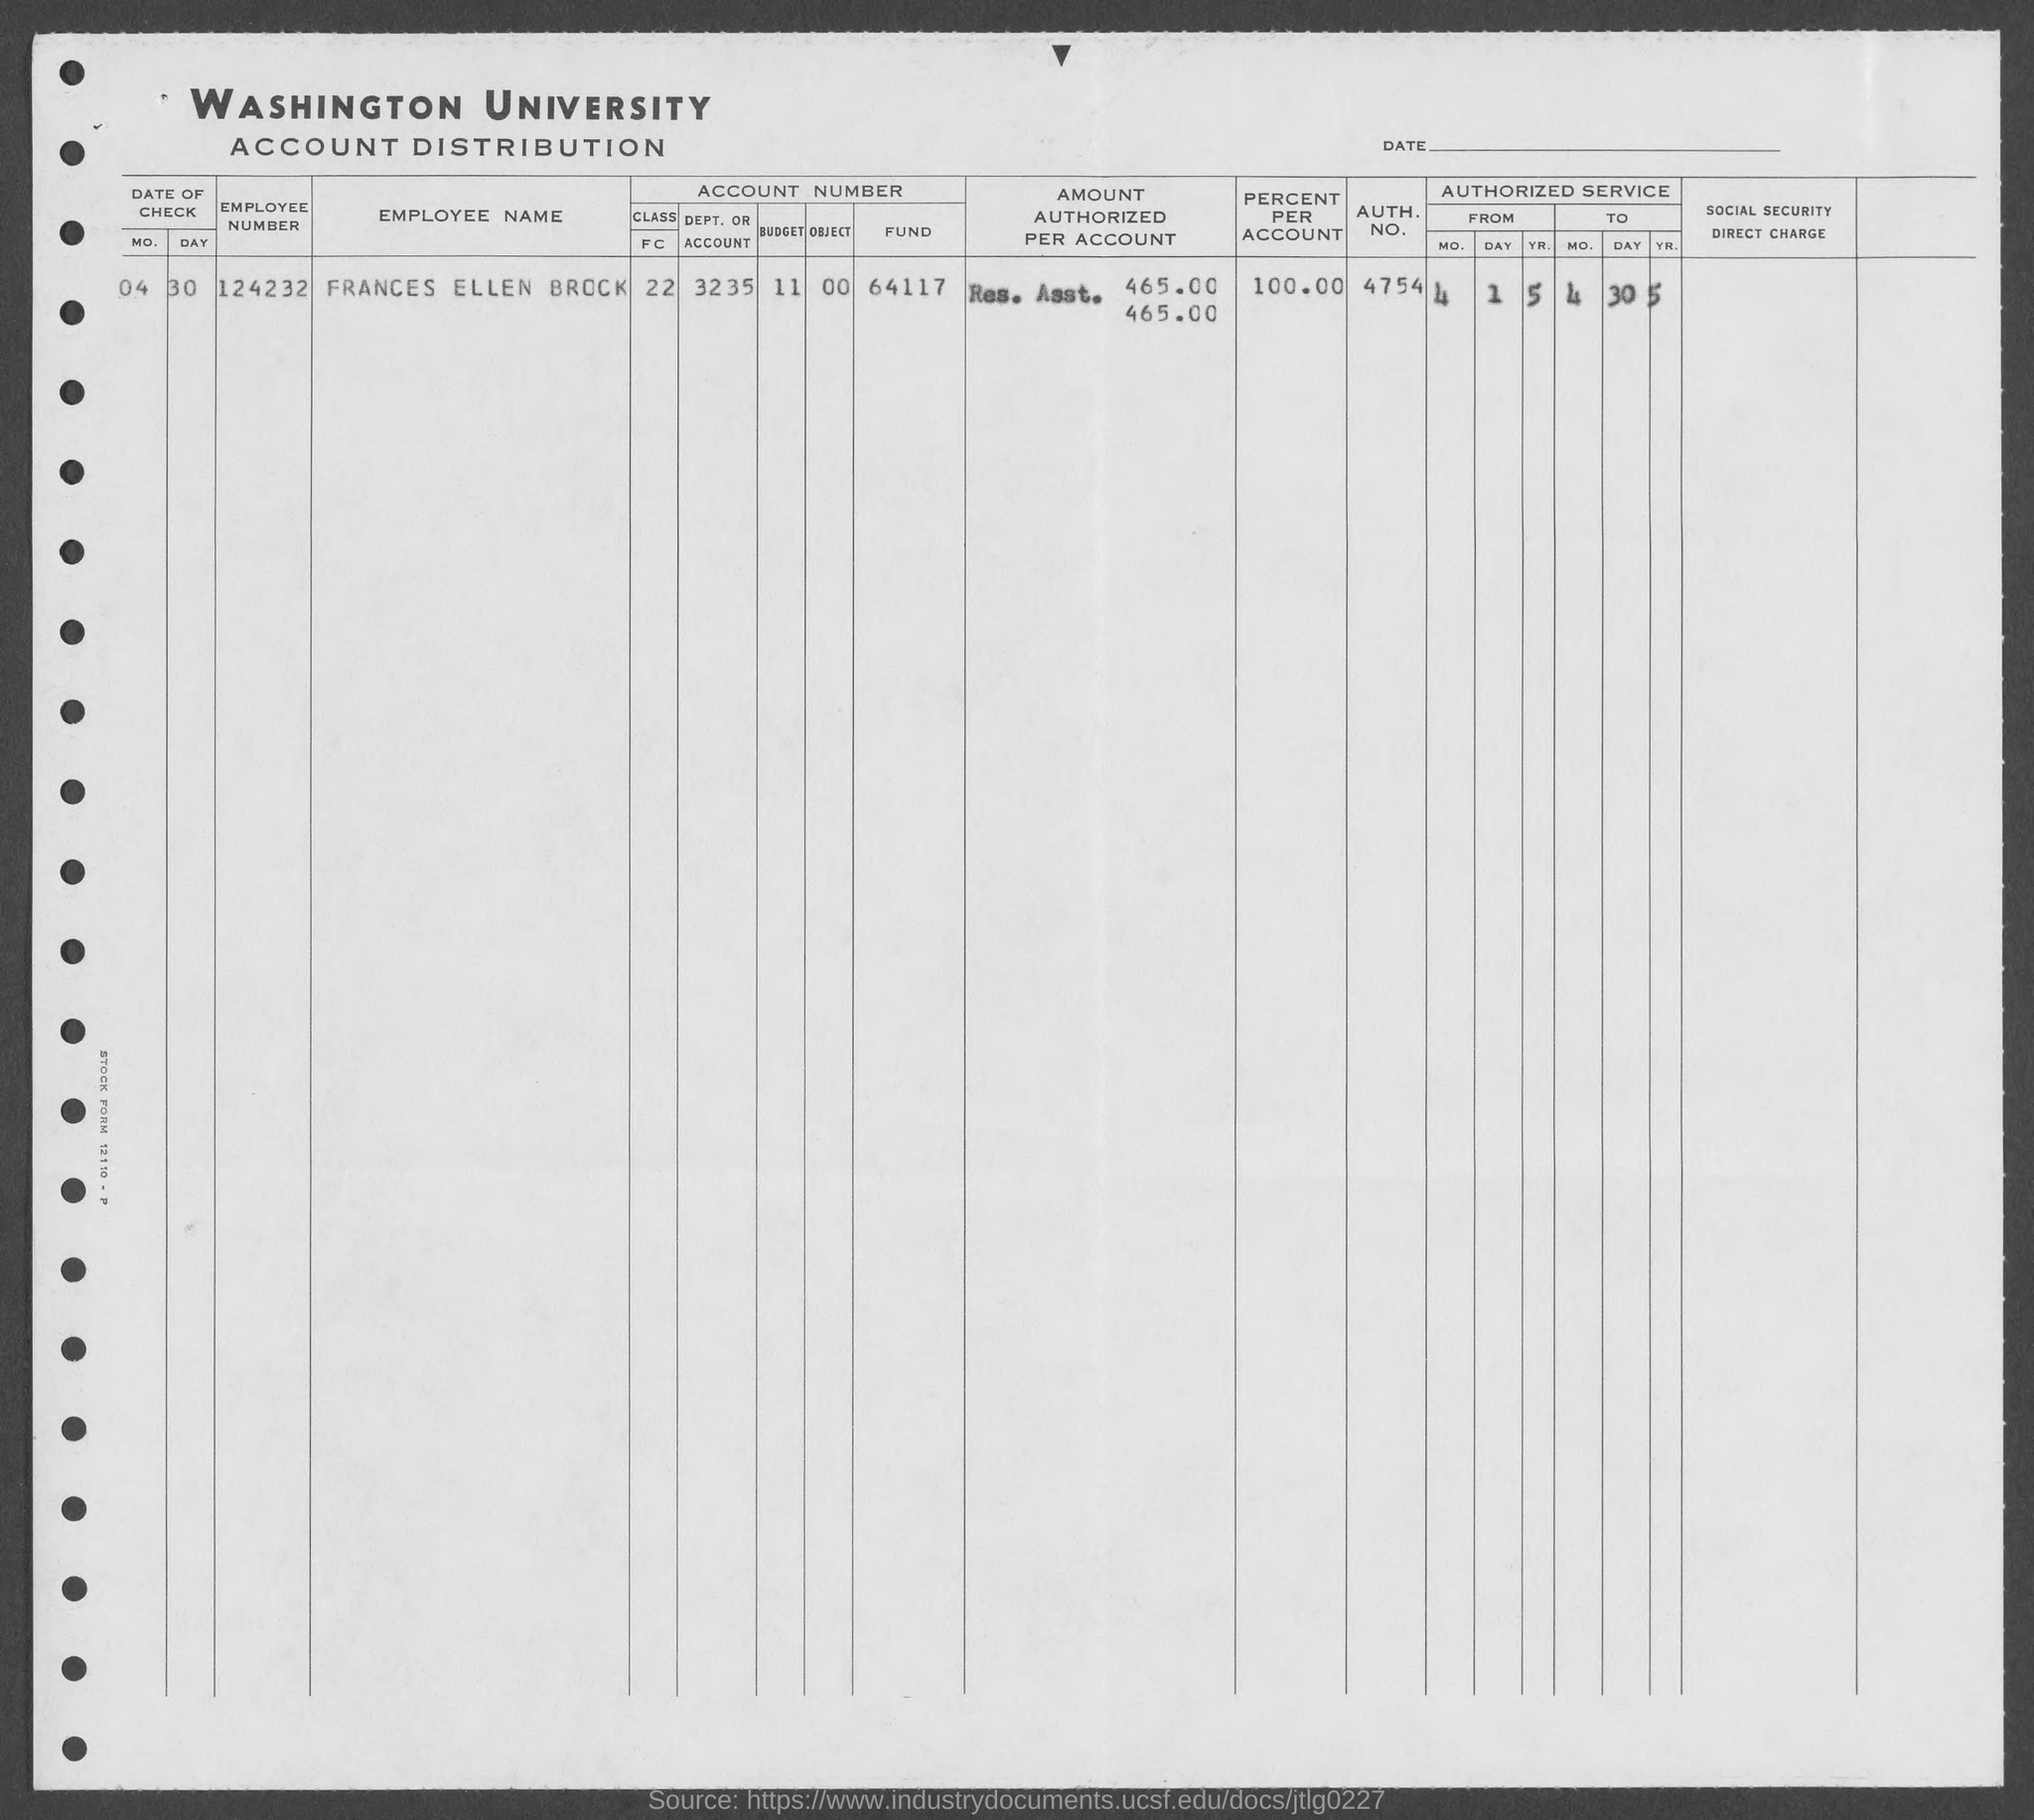What is the name of the university mentioned in the given form ?
Your answer should be compact. Washington University. What is the employee number mentioned in the given form ?
Your answer should be very brief. 124232. What is the employee name mentioned in the given form ?
Make the answer very short. Frances Ellen Brock. What is the amount of fund mentioned in the given form ?
Give a very brief answer. 64117. What is the value of percent per account as mentioned in the given form ?
Ensure brevity in your answer.  100.00. What is the auth. no. mentioned in the given form ?
Your response must be concise. 4754. What is the budget no. mentioned in the given form ?
Offer a very short reply. 11. What is the dept. or account number mentioned in the given form ?
Your response must be concise. 3235. What is the object no. mentioned in the given form ?
Your response must be concise. 00. What is the mo. number mentioned in the given form ?
Your response must be concise. 04. 